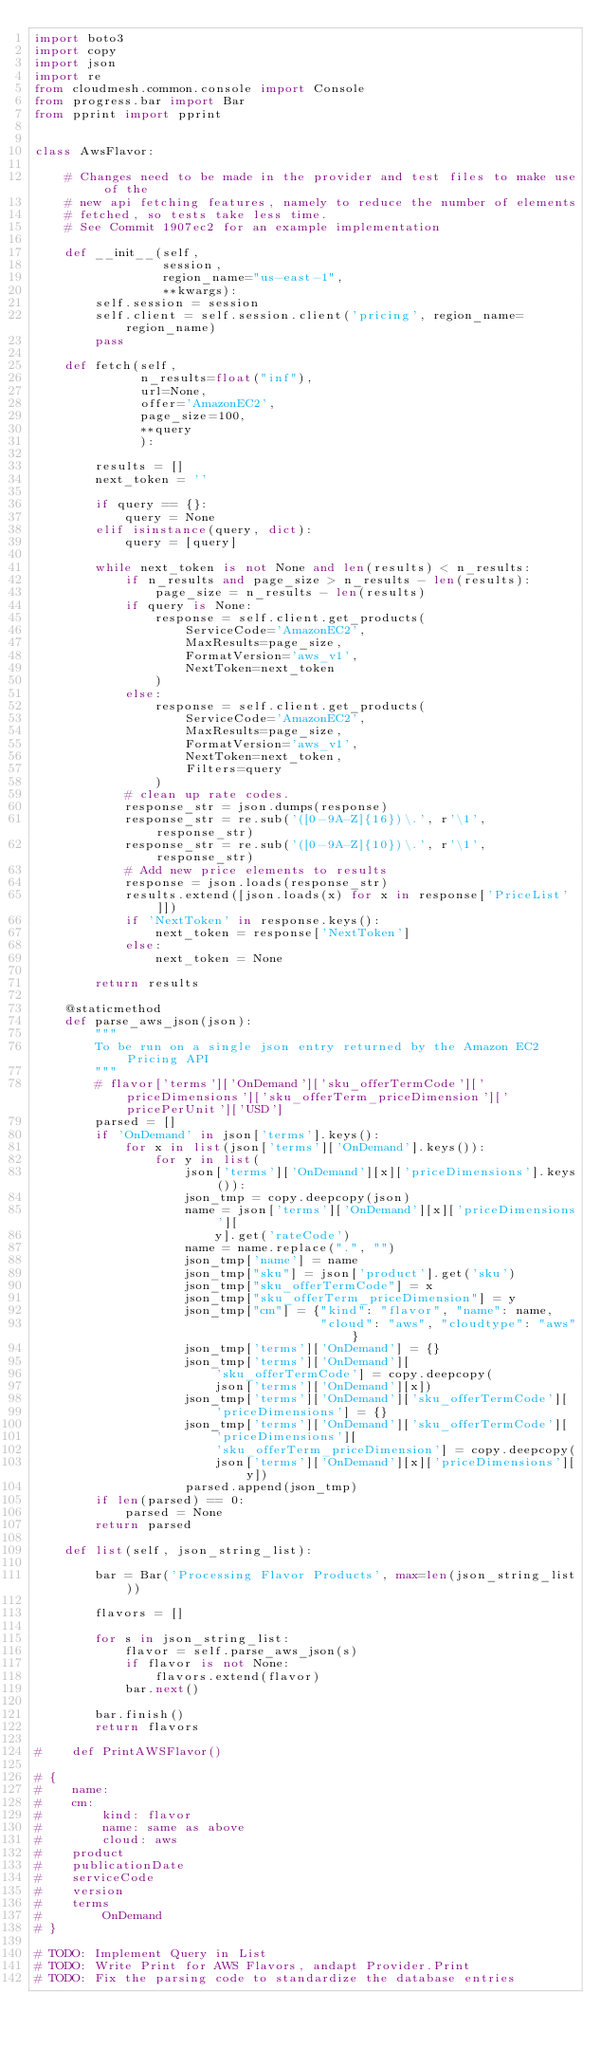<code> <loc_0><loc_0><loc_500><loc_500><_Python_>import boto3
import copy
import json
import re
from cloudmesh.common.console import Console
from progress.bar import Bar
from pprint import pprint


class AwsFlavor:

    # Changes need to be made in the provider and test files to make use of the
    # new api fetching features, namely to reduce the number of elements
    # fetched, so tests take less time.
    # See Commit 1907ec2 for an example implementation

    def __init__(self,
                 session,
                 region_name="us-east-1",
                 **kwargs):
        self.session = session
        self.client = self.session.client('pricing', region_name=region_name)
        pass

    def fetch(self,
              n_results=float("inf"),
              url=None,
              offer='AmazonEC2',
              page_size=100,
              **query
              ):

        results = []
        next_token = ''

        if query == {}:
            query = None
        elif isinstance(query, dict):
            query = [query]

        while next_token is not None and len(results) < n_results:
            if n_results and page_size > n_results - len(results):
                page_size = n_results - len(results)
            if query is None:
                response = self.client.get_products(
                    ServiceCode='AmazonEC2',
                    MaxResults=page_size,
                    FormatVersion='aws_v1',
                    NextToken=next_token
                )
            else:
                response = self.client.get_products(
                    ServiceCode='AmazonEC2',
                    MaxResults=page_size,
                    FormatVersion='aws_v1',
                    NextToken=next_token,
                    Filters=query
                )
            # clean up rate codes.
            response_str = json.dumps(response)
            response_str = re.sub('([0-9A-Z]{16})\.', r'\1', response_str)
            response_str = re.sub('([0-9A-Z]{10})\.', r'\1', response_str)
            # Add new price elements to results
            response = json.loads(response_str)
            results.extend([json.loads(x) for x in response['PriceList']])
            if 'NextToken' in response.keys():
                next_token = response['NextToken']
            else:
                next_token = None

        return results

    @staticmethod
    def parse_aws_json(json):
        """
        To be run on a single json entry returned by the Amazon EC2 Pricing API
        """
        # flavor['terms']['OnDemand']['sku_offerTermCode']['priceDimensions']['sku_offerTerm_priceDimension']['pricePerUnit']['USD']
        parsed = []
        if 'OnDemand' in json['terms'].keys():
            for x in list(json['terms']['OnDemand'].keys()):
                for y in list(
                    json['terms']['OnDemand'][x]['priceDimensions'].keys()):
                    json_tmp = copy.deepcopy(json)
                    name = json['terms']['OnDemand'][x]['priceDimensions'][
                        y].get('rateCode')
                    name = name.replace(".", "")
                    json_tmp['name'] = name
                    json_tmp["sku"] = json['product'].get('sku')
                    json_tmp["sku_offerTermCode"] = x
                    json_tmp["sku_offerTerm_priceDimension"] = y
                    json_tmp["cm"] = {"kind": "flavor", "name": name,
                                      "cloud": "aws", "cloudtype": "aws"}
                    json_tmp['terms']['OnDemand'] = {}
                    json_tmp['terms']['OnDemand'][
                        'sku_offerTermCode'] = copy.deepcopy(
                        json['terms']['OnDemand'][x])
                    json_tmp['terms']['OnDemand']['sku_offerTermCode'][
                        'priceDimensions'] = {}
                    json_tmp['terms']['OnDemand']['sku_offerTermCode'][
                        'priceDimensions'][
                        'sku_offerTerm_priceDimension'] = copy.deepcopy(
                        json['terms']['OnDemand'][x]['priceDimensions'][y])
                    parsed.append(json_tmp)
        if len(parsed) == 0:
            parsed = None
        return parsed

    def list(self, json_string_list):

        bar = Bar('Processing Flavor Products', max=len(json_string_list))

        flavors = []

        for s in json_string_list:
            flavor = self.parse_aws_json(s)
            if flavor is not None:
                flavors.extend(flavor)
            bar.next()

        bar.finish()
        return flavors

#    def PrintAWSFlavor()

# {
#    name:
#    cm:
#        kind: flavor
#        name: same as above
#        cloud: aws
#    product
#    publicationDate
#    serviceCode
#    version
#    terms
#        OnDemand
# }

# TODO: Implement Query in List
# TODO: Write Print for AWS Flavors, andapt Provider.Print
# TODO: Fix the parsing code to standardize the database entries
</code> 